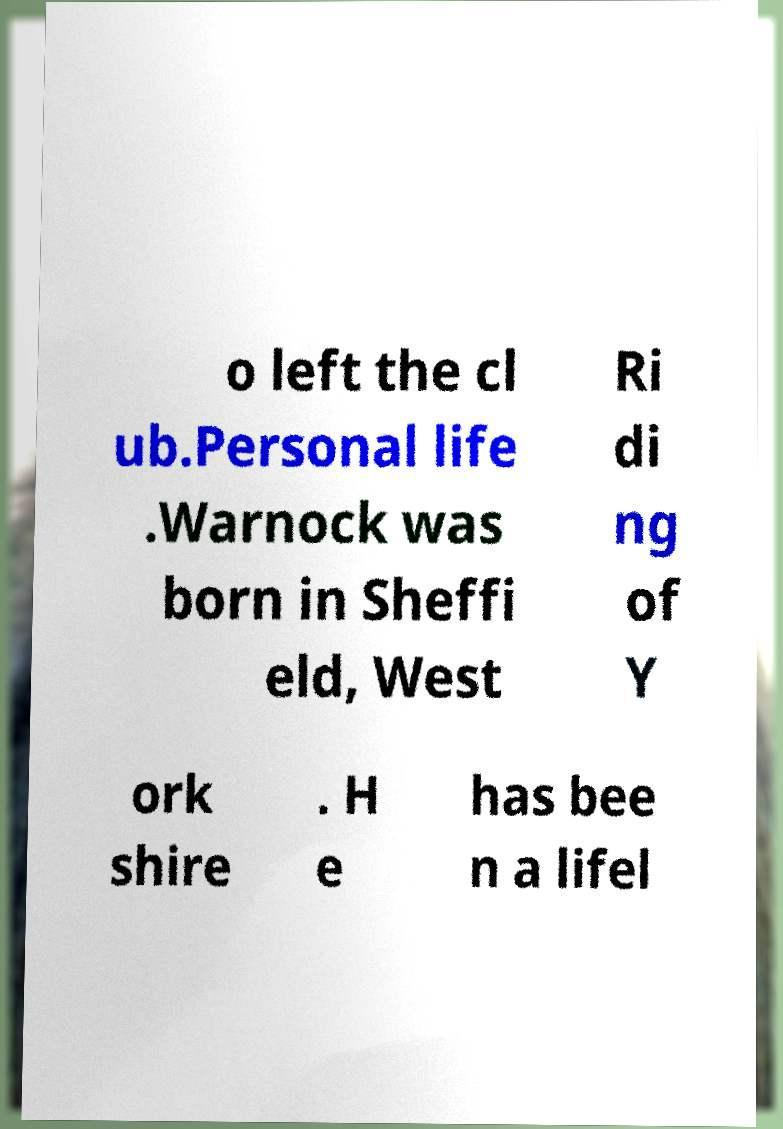For documentation purposes, I need the text within this image transcribed. Could you provide that? o left the cl ub.Personal life .Warnock was born in Sheffi eld, West Ri di ng of Y ork shire . H e has bee n a lifel 